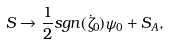Convert formula to latex. <formula><loc_0><loc_0><loc_500><loc_500>S \to \frac { 1 } { 2 } s g n ( \dot { \zeta } _ { 0 } ) \psi _ { 0 } + S _ { A } ,</formula> 